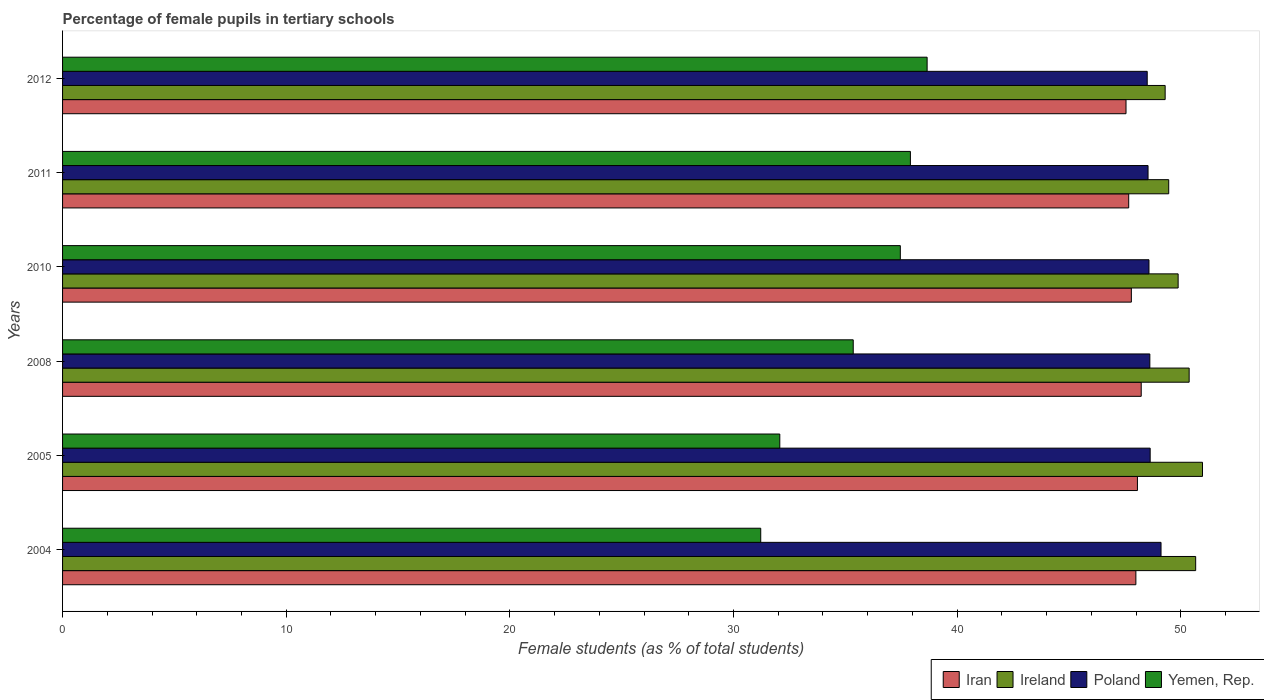How many groups of bars are there?
Provide a short and direct response. 6. Are the number of bars on each tick of the Y-axis equal?
Give a very brief answer. Yes. What is the label of the 4th group of bars from the top?
Your response must be concise. 2008. In how many cases, is the number of bars for a given year not equal to the number of legend labels?
Give a very brief answer. 0. What is the percentage of female pupils in tertiary schools in Poland in 2008?
Keep it short and to the point. 48.62. Across all years, what is the maximum percentage of female pupils in tertiary schools in Yemen, Rep.?
Ensure brevity in your answer.  38.66. Across all years, what is the minimum percentage of female pupils in tertiary schools in Iran?
Provide a succinct answer. 47.55. In which year was the percentage of female pupils in tertiary schools in Poland maximum?
Make the answer very short. 2004. In which year was the percentage of female pupils in tertiary schools in Iran minimum?
Give a very brief answer. 2012. What is the total percentage of female pupils in tertiary schools in Iran in the graph?
Ensure brevity in your answer.  287.3. What is the difference between the percentage of female pupils in tertiary schools in Iran in 2004 and that in 2005?
Provide a succinct answer. -0.07. What is the difference between the percentage of female pupils in tertiary schools in Yemen, Rep. in 2010 and the percentage of female pupils in tertiary schools in Iran in 2005?
Your answer should be compact. -10.6. What is the average percentage of female pupils in tertiary schools in Poland per year?
Give a very brief answer. 48.66. In the year 2004, what is the difference between the percentage of female pupils in tertiary schools in Ireland and percentage of female pupils in tertiary schools in Yemen, Rep.?
Provide a succinct answer. 19.45. What is the ratio of the percentage of female pupils in tertiary schools in Ireland in 2010 to that in 2011?
Ensure brevity in your answer.  1.01. Is the difference between the percentage of female pupils in tertiary schools in Ireland in 2011 and 2012 greater than the difference between the percentage of female pupils in tertiary schools in Yemen, Rep. in 2011 and 2012?
Your response must be concise. Yes. What is the difference between the highest and the second highest percentage of female pupils in tertiary schools in Poland?
Offer a terse response. 0.49. What is the difference between the highest and the lowest percentage of female pupils in tertiary schools in Iran?
Make the answer very short. 0.68. What does the 4th bar from the top in 2011 represents?
Offer a very short reply. Iran. What does the 1st bar from the bottom in 2011 represents?
Offer a very short reply. Iran. Is it the case that in every year, the sum of the percentage of female pupils in tertiary schools in Iran and percentage of female pupils in tertiary schools in Ireland is greater than the percentage of female pupils in tertiary schools in Poland?
Your answer should be compact. Yes. How many bars are there?
Ensure brevity in your answer.  24. Are all the bars in the graph horizontal?
Keep it short and to the point. Yes. How many years are there in the graph?
Your response must be concise. 6. Are the values on the major ticks of X-axis written in scientific E-notation?
Your answer should be compact. No. What is the title of the graph?
Provide a short and direct response. Percentage of female pupils in tertiary schools. Does "Channel Islands" appear as one of the legend labels in the graph?
Your response must be concise. No. What is the label or title of the X-axis?
Provide a short and direct response. Female students (as % of total students). What is the label or title of the Y-axis?
Keep it short and to the point. Years. What is the Female students (as % of total students) in Iran in 2004?
Provide a short and direct response. 47.99. What is the Female students (as % of total students) in Ireland in 2004?
Make the answer very short. 50.67. What is the Female students (as % of total students) of Poland in 2004?
Offer a terse response. 49.12. What is the Female students (as % of total students) of Yemen, Rep. in 2004?
Your response must be concise. 31.22. What is the Female students (as % of total students) in Iran in 2005?
Keep it short and to the point. 48.06. What is the Female students (as % of total students) of Ireland in 2005?
Ensure brevity in your answer.  50.97. What is the Female students (as % of total students) of Poland in 2005?
Give a very brief answer. 48.63. What is the Female students (as % of total students) of Yemen, Rep. in 2005?
Ensure brevity in your answer.  32.07. What is the Female students (as % of total students) in Iran in 2008?
Offer a terse response. 48.23. What is the Female students (as % of total students) in Ireland in 2008?
Keep it short and to the point. 50.38. What is the Female students (as % of total students) in Poland in 2008?
Ensure brevity in your answer.  48.62. What is the Female students (as % of total students) of Yemen, Rep. in 2008?
Provide a short and direct response. 35.35. What is the Female students (as % of total students) of Iran in 2010?
Offer a very short reply. 47.79. What is the Female students (as % of total students) of Ireland in 2010?
Your answer should be compact. 49.88. What is the Female students (as % of total students) in Poland in 2010?
Ensure brevity in your answer.  48.58. What is the Female students (as % of total students) in Yemen, Rep. in 2010?
Your response must be concise. 37.46. What is the Female students (as % of total students) of Iran in 2011?
Your answer should be very brief. 47.67. What is the Female students (as % of total students) in Ireland in 2011?
Make the answer very short. 49.46. What is the Female students (as % of total students) in Poland in 2011?
Provide a succinct answer. 48.54. What is the Female students (as % of total students) of Yemen, Rep. in 2011?
Provide a succinct answer. 37.91. What is the Female students (as % of total students) in Iran in 2012?
Keep it short and to the point. 47.55. What is the Female students (as % of total students) of Ireland in 2012?
Offer a very short reply. 49.3. What is the Female students (as % of total students) in Poland in 2012?
Make the answer very short. 48.5. What is the Female students (as % of total students) in Yemen, Rep. in 2012?
Your response must be concise. 38.66. Across all years, what is the maximum Female students (as % of total students) in Iran?
Offer a terse response. 48.23. Across all years, what is the maximum Female students (as % of total students) in Ireland?
Keep it short and to the point. 50.97. Across all years, what is the maximum Female students (as % of total students) of Poland?
Provide a succinct answer. 49.12. Across all years, what is the maximum Female students (as % of total students) in Yemen, Rep.?
Keep it short and to the point. 38.66. Across all years, what is the minimum Female students (as % of total students) of Iran?
Make the answer very short. 47.55. Across all years, what is the minimum Female students (as % of total students) in Ireland?
Offer a terse response. 49.3. Across all years, what is the minimum Female students (as % of total students) of Poland?
Make the answer very short. 48.5. Across all years, what is the minimum Female students (as % of total students) of Yemen, Rep.?
Make the answer very short. 31.22. What is the total Female students (as % of total students) in Iran in the graph?
Provide a short and direct response. 287.3. What is the total Female students (as % of total students) of Ireland in the graph?
Your answer should be very brief. 300.66. What is the total Female students (as % of total students) of Poland in the graph?
Make the answer very short. 291.98. What is the total Female students (as % of total students) in Yemen, Rep. in the graph?
Provide a short and direct response. 212.67. What is the difference between the Female students (as % of total students) in Iran in 2004 and that in 2005?
Offer a very short reply. -0.07. What is the difference between the Female students (as % of total students) of Ireland in 2004 and that in 2005?
Offer a terse response. -0.3. What is the difference between the Female students (as % of total students) in Poland in 2004 and that in 2005?
Your response must be concise. 0.49. What is the difference between the Female students (as % of total students) of Yemen, Rep. in 2004 and that in 2005?
Offer a terse response. -0.85. What is the difference between the Female students (as % of total students) in Iran in 2004 and that in 2008?
Provide a short and direct response. -0.24. What is the difference between the Female students (as % of total students) in Ireland in 2004 and that in 2008?
Make the answer very short. 0.29. What is the difference between the Female students (as % of total students) in Poland in 2004 and that in 2008?
Give a very brief answer. 0.5. What is the difference between the Female students (as % of total students) in Yemen, Rep. in 2004 and that in 2008?
Ensure brevity in your answer.  -4.14. What is the difference between the Female students (as % of total students) of Iran in 2004 and that in 2010?
Make the answer very short. 0.2. What is the difference between the Female students (as % of total students) in Ireland in 2004 and that in 2010?
Your answer should be compact. 0.78. What is the difference between the Female students (as % of total students) of Poland in 2004 and that in 2010?
Keep it short and to the point. 0.54. What is the difference between the Female students (as % of total students) in Yemen, Rep. in 2004 and that in 2010?
Give a very brief answer. -6.24. What is the difference between the Female students (as % of total students) in Iran in 2004 and that in 2011?
Provide a short and direct response. 0.32. What is the difference between the Female students (as % of total students) in Ireland in 2004 and that in 2011?
Provide a succinct answer. 1.21. What is the difference between the Female students (as % of total students) in Poland in 2004 and that in 2011?
Offer a very short reply. 0.58. What is the difference between the Female students (as % of total students) of Yemen, Rep. in 2004 and that in 2011?
Your answer should be very brief. -6.69. What is the difference between the Female students (as % of total students) of Iran in 2004 and that in 2012?
Offer a very short reply. 0.44. What is the difference between the Female students (as % of total students) in Ireland in 2004 and that in 2012?
Your answer should be very brief. 1.36. What is the difference between the Female students (as % of total students) in Poland in 2004 and that in 2012?
Offer a very short reply. 0.62. What is the difference between the Female students (as % of total students) of Yemen, Rep. in 2004 and that in 2012?
Give a very brief answer. -7.44. What is the difference between the Female students (as % of total students) in Iran in 2005 and that in 2008?
Offer a terse response. -0.17. What is the difference between the Female students (as % of total students) in Ireland in 2005 and that in 2008?
Your answer should be very brief. 0.6. What is the difference between the Female students (as % of total students) of Poland in 2005 and that in 2008?
Your answer should be very brief. 0.01. What is the difference between the Female students (as % of total students) in Yemen, Rep. in 2005 and that in 2008?
Provide a succinct answer. -3.28. What is the difference between the Female students (as % of total students) in Iran in 2005 and that in 2010?
Keep it short and to the point. 0.27. What is the difference between the Female students (as % of total students) in Ireland in 2005 and that in 2010?
Keep it short and to the point. 1.09. What is the difference between the Female students (as % of total students) of Poland in 2005 and that in 2010?
Provide a succinct answer. 0.05. What is the difference between the Female students (as % of total students) in Yemen, Rep. in 2005 and that in 2010?
Ensure brevity in your answer.  -5.39. What is the difference between the Female students (as % of total students) in Iran in 2005 and that in 2011?
Offer a terse response. 0.39. What is the difference between the Female students (as % of total students) in Ireland in 2005 and that in 2011?
Your response must be concise. 1.51. What is the difference between the Female students (as % of total students) of Poland in 2005 and that in 2011?
Give a very brief answer. 0.09. What is the difference between the Female students (as % of total students) of Yemen, Rep. in 2005 and that in 2011?
Provide a short and direct response. -5.84. What is the difference between the Female students (as % of total students) of Iran in 2005 and that in 2012?
Keep it short and to the point. 0.51. What is the difference between the Female students (as % of total students) in Ireland in 2005 and that in 2012?
Offer a very short reply. 1.67. What is the difference between the Female students (as % of total students) in Poland in 2005 and that in 2012?
Provide a succinct answer. 0.13. What is the difference between the Female students (as % of total students) in Yemen, Rep. in 2005 and that in 2012?
Make the answer very short. -6.59. What is the difference between the Female students (as % of total students) of Iran in 2008 and that in 2010?
Keep it short and to the point. 0.44. What is the difference between the Female students (as % of total students) in Ireland in 2008 and that in 2010?
Your answer should be compact. 0.49. What is the difference between the Female students (as % of total students) in Poland in 2008 and that in 2010?
Make the answer very short. 0.04. What is the difference between the Female students (as % of total students) of Yemen, Rep. in 2008 and that in 2010?
Offer a very short reply. -2.11. What is the difference between the Female students (as % of total students) in Iran in 2008 and that in 2011?
Make the answer very short. 0.56. What is the difference between the Female students (as % of total students) in Ireland in 2008 and that in 2011?
Keep it short and to the point. 0.91. What is the difference between the Female students (as % of total students) in Poland in 2008 and that in 2011?
Make the answer very short. 0.08. What is the difference between the Female students (as % of total students) in Yemen, Rep. in 2008 and that in 2011?
Your answer should be very brief. -2.56. What is the difference between the Female students (as % of total students) of Iran in 2008 and that in 2012?
Your answer should be compact. 0.68. What is the difference between the Female students (as % of total students) in Ireland in 2008 and that in 2012?
Provide a succinct answer. 1.07. What is the difference between the Female students (as % of total students) in Poland in 2008 and that in 2012?
Give a very brief answer. 0.12. What is the difference between the Female students (as % of total students) in Yemen, Rep. in 2008 and that in 2012?
Keep it short and to the point. -3.3. What is the difference between the Female students (as % of total students) of Iran in 2010 and that in 2011?
Your answer should be very brief. 0.12. What is the difference between the Female students (as % of total students) in Ireland in 2010 and that in 2011?
Your answer should be very brief. 0.42. What is the difference between the Female students (as % of total students) of Poland in 2010 and that in 2011?
Your answer should be very brief. 0.04. What is the difference between the Female students (as % of total students) of Yemen, Rep. in 2010 and that in 2011?
Ensure brevity in your answer.  -0.45. What is the difference between the Female students (as % of total students) in Iran in 2010 and that in 2012?
Give a very brief answer. 0.24. What is the difference between the Female students (as % of total students) in Ireland in 2010 and that in 2012?
Offer a terse response. 0.58. What is the difference between the Female students (as % of total students) of Poland in 2010 and that in 2012?
Your answer should be very brief. 0.08. What is the difference between the Female students (as % of total students) of Yemen, Rep. in 2010 and that in 2012?
Make the answer very short. -1.2. What is the difference between the Female students (as % of total students) in Iran in 2011 and that in 2012?
Your answer should be compact. 0.12. What is the difference between the Female students (as % of total students) of Ireland in 2011 and that in 2012?
Your response must be concise. 0.16. What is the difference between the Female students (as % of total students) in Poland in 2011 and that in 2012?
Provide a short and direct response. 0.04. What is the difference between the Female students (as % of total students) of Yemen, Rep. in 2011 and that in 2012?
Your answer should be very brief. -0.75. What is the difference between the Female students (as % of total students) in Iran in 2004 and the Female students (as % of total students) in Ireland in 2005?
Make the answer very short. -2.98. What is the difference between the Female students (as % of total students) of Iran in 2004 and the Female students (as % of total students) of Poland in 2005?
Offer a very short reply. -0.64. What is the difference between the Female students (as % of total students) in Iran in 2004 and the Female students (as % of total students) in Yemen, Rep. in 2005?
Offer a very short reply. 15.92. What is the difference between the Female students (as % of total students) of Ireland in 2004 and the Female students (as % of total students) of Poland in 2005?
Make the answer very short. 2.03. What is the difference between the Female students (as % of total students) of Ireland in 2004 and the Female students (as % of total students) of Yemen, Rep. in 2005?
Give a very brief answer. 18.6. What is the difference between the Female students (as % of total students) of Poland in 2004 and the Female students (as % of total students) of Yemen, Rep. in 2005?
Provide a short and direct response. 17.05. What is the difference between the Female students (as % of total students) in Iran in 2004 and the Female students (as % of total students) in Ireland in 2008?
Give a very brief answer. -2.38. What is the difference between the Female students (as % of total students) of Iran in 2004 and the Female students (as % of total students) of Poland in 2008?
Your response must be concise. -0.62. What is the difference between the Female students (as % of total students) in Iran in 2004 and the Female students (as % of total students) in Yemen, Rep. in 2008?
Ensure brevity in your answer.  12.64. What is the difference between the Female students (as % of total students) of Ireland in 2004 and the Female students (as % of total students) of Poland in 2008?
Ensure brevity in your answer.  2.05. What is the difference between the Female students (as % of total students) in Ireland in 2004 and the Female students (as % of total students) in Yemen, Rep. in 2008?
Your response must be concise. 15.31. What is the difference between the Female students (as % of total students) of Poland in 2004 and the Female students (as % of total students) of Yemen, Rep. in 2008?
Make the answer very short. 13.76. What is the difference between the Female students (as % of total students) in Iran in 2004 and the Female students (as % of total students) in Ireland in 2010?
Provide a short and direct response. -1.89. What is the difference between the Female students (as % of total students) of Iran in 2004 and the Female students (as % of total students) of Poland in 2010?
Your response must be concise. -0.59. What is the difference between the Female students (as % of total students) of Iran in 2004 and the Female students (as % of total students) of Yemen, Rep. in 2010?
Provide a short and direct response. 10.53. What is the difference between the Female students (as % of total students) of Ireland in 2004 and the Female students (as % of total students) of Poland in 2010?
Your answer should be compact. 2.09. What is the difference between the Female students (as % of total students) in Ireland in 2004 and the Female students (as % of total students) in Yemen, Rep. in 2010?
Your answer should be very brief. 13.21. What is the difference between the Female students (as % of total students) in Poland in 2004 and the Female students (as % of total students) in Yemen, Rep. in 2010?
Provide a succinct answer. 11.66. What is the difference between the Female students (as % of total students) of Iran in 2004 and the Female students (as % of total students) of Ireland in 2011?
Offer a very short reply. -1.47. What is the difference between the Female students (as % of total students) in Iran in 2004 and the Female students (as % of total students) in Poland in 2011?
Provide a succinct answer. -0.54. What is the difference between the Female students (as % of total students) of Iran in 2004 and the Female students (as % of total students) of Yemen, Rep. in 2011?
Ensure brevity in your answer.  10.08. What is the difference between the Female students (as % of total students) of Ireland in 2004 and the Female students (as % of total students) of Poland in 2011?
Give a very brief answer. 2.13. What is the difference between the Female students (as % of total students) in Ireland in 2004 and the Female students (as % of total students) in Yemen, Rep. in 2011?
Ensure brevity in your answer.  12.76. What is the difference between the Female students (as % of total students) in Poland in 2004 and the Female students (as % of total students) in Yemen, Rep. in 2011?
Provide a short and direct response. 11.21. What is the difference between the Female students (as % of total students) of Iran in 2004 and the Female students (as % of total students) of Ireland in 2012?
Your response must be concise. -1.31. What is the difference between the Female students (as % of total students) in Iran in 2004 and the Female students (as % of total students) in Poland in 2012?
Make the answer very short. -0.51. What is the difference between the Female students (as % of total students) in Iran in 2004 and the Female students (as % of total students) in Yemen, Rep. in 2012?
Make the answer very short. 9.33. What is the difference between the Female students (as % of total students) in Ireland in 2004 and the Female students (as % of total students) in Poland in 2012?
Ensure brevity in your answer.  2.17. What is the difference between the Female students (as % of total students) in Ireland in 2004 and the Female students (as % of total students) in Yemen, Rep. in 2012?
Your answer should be compact. 12.01. What is the difference between the Female students (as % of total students) in Poland in 2004 and the Female students (as % of total students) in Yemen, Rep. in 2012?
Provide a succinct answer. 10.46. What is the difference between the Female students (as % of total students) of Iran in 2005 and the Female students (as % of total students) of Ireland in 2008?
Make the answer very short. -2.31. What is the difference between the Female students (as % of total students) in Iran in 2005 and the Female students (as % of total students) in Poland in 2008?
Give a very brief answer. -0.56. What is the difference between the Female students (as % of total students) in Iran in 2005 and the Female students (as % of total students) in Yemen, Rep. in 2008?
Make the answer very short. 12.71. What is the difference between the Female students (as % of total students) in Ireland in 2005 and the Female students (as % of total students) in Poland in 2008?
Provide a short and direct response. 2.35. What is the difference between the Female students (as % of total students) of Ireland in 2005 and the Female students (as % of total students) of Yemen, Rep. in 2008?
Your answer should be compact. 15.62. What is the difference between the Female students (as % of total students) in Poland in 2005 and the Female students (as % of total students) in Yemen, Rep. in 2008?
Offer a terse response. 13.28. What is the difference between the Female students (as % of total students) in Iran in 2005 and the Female students (as % of total students) in Ireland in 2010?
Provide a short and direct response. -1.82. What is the difference between the Female students (as % of total students) in Iran in 2005 and the Female students (as % of total students) in Poland in 2010?
Ensure brevity in your answer.  -0.52. What is the difference between the Female students (as % of total students) of Iran in 2005 and the Female students (as % of total students) of Yemen, Rep. in 2010?
Keep it short and to the point. 10.6. What is the difference between the Female students (as % of total students) in Ireland in 2005 and the Female students (as % of total students) in Poland in 2010?
Give a very brief answer. 2.39. What is the difference between the Female students (as % of total students) of Ireland in 2005 and the Female students (as % of total students) of Yemen, Rep. in 2010?
Ensure brevity in your answer.  13.51. What is the difference between the Female students (as % of total students) in Poland in 2005 and the Female students (as % of total students) in Yemen, Rep. in 2010?
Provide a short and direct response. 11.17. What is the difference between the Female students (as % of total students) in Iran in 2005 and the Female students (as % of total students) in Ireland in 2011?
Give a very brief answer. -1.4. What is the difference between the Female students (as % of total students) of Iran in 2005 and the Female students (as % of total students) of Poland in 2011?
Offer a terse response. -0.47. What is the difference between the Female students (as % of total students) of Iran in 2005 and the Female students (as % of total students) of Yemen, Rep. in 2011?
Provide a succinct answer. 10.15. What is the difference between the Female students (as % of total students) in Ireland in 2005 and the Female students (as % of total students) in Poland in 2011?
Keep it short and to the point. 2.43. What is the difference between the Female students (as % of total students) in Ireland in 2005 and the Female students (as % of total students) in Yemen, Rep. in 2011?
Offer a terse response. 13.06. What is the difference between the Female students (as % of total students) of Poland in 2005 and the Female students (as % of total students) of Yemen, Rep. in 2011?
Keep it short and to the point. 10.72. What is the difference between the Female students (as % of total students) of Iran in 2005 and the Female students (as % of total students) of Ireland in 2012?
Provide a succinct answer. -1.24. What is the difference between the Female students (as % of total students) of Iran in 2005 and the Female students (as % of total students) of Poland in 2012?
Ensure brevity in your answer.  -0.44. What is the difference between the Female students (as % of total students) of Iran in 2005 and the Female students (as % of total students) of Yemen, Rep. in 2012?
Offer a very short reply. 9.4. What is the difference between the Female students (as % of total students) in Ireland in 2005 and the Female students (as % of total students) in Poland in 2012?
Offer a very short reply. 2.47. What is the difference between the Female students (as % of total students) in Ireland in 2005 and the Female students (as % of total students) in Yemen, Rep. in 2012?
Your response must be concise. 12.31. What is the difference between the Female students (as % of total students) of Poland in 2005 and the Female students (as % of total students) of Yemen, Rep. in 2012?
Ensure brevity in your answer.  9.97. What is the difference between the Female students (as % of total students) of Iran in 2008 and the Female students (as % of total students) of Ireland in 2010?
Provide a succinct answer. -1.65. What is the difference between the Female students (as % of total students) of Iran in 2008 and the Female students (as % of total students) of Poland in 2010?
Make the answer very short. -0.35. What is the difference between the Female students (as % of total students) of Iran in 2008 and the Female students (as % of total students) of Yemen, Rep. in 2010?
Ensure brevity in your answer.  10.77. What is the difference between the Female students (as % of total students) in Ireland in 2008 and the Female students (as % of total students) in Poland in 2010?
Make the answer very short. 1.8. What is the difference between the Female students (as % of total students) in Ireland in 2008 and the Female students (as % of total students) in Yemen, Rep. in 2010?
Make the answer very short. 12.92. What is the difference between the Female students (as % of total students) in Poland in 2008 and the Female students (as % of total students) in Yemen, Rep. in 2010?
Your response must be concise. 11.16. What is the difference between the Female students (as % of total students) of Iran in 2008 and the Female students (as % of total students) of Ireland in 2011?
Give a very brief answer. -1.23. What is the difference between the Female students (as % of total students) of Iran in 2008 and the Female students (as % of total students) of Poland in 2011?
Your answer should be compact. -0.31. What is the difference between the Female students (as % of total students) in Iran in 2008 and the Female students (as % of total students) in Yemen, Rep. in 2011?
Offer a terse response. 10.32. What is the difference between the Female students (as % of total students) of Ireland in 2008 and the Female students (as % of total students) of Poland in 2011?
Provide a succinct answer. 1.84. What is the difference between the Female students (as % of total students) in Ireland in 2008 and the Female students (as % of total students) in Yemen, Rep. in 2011?
Keep it short and to the point. 12.46. What is the difference between the Female students (as % of total students) in Poland in 2008 and the Female students (as % of total students) in Yemen, Rep. in 2011?
Your response must be concise. 10.71. What is the difference between the Female students (as % of total students) of Iran in 2008 and the Female students (as % of total students) of Ireland in 2012?
Ensure brevity in your answer.  -1.07. What is the difference between the Female students (as % of total students) in Iran in 2008 and the Female students (as % of total students) in Poland in 2012?
Your answer should be compact. -0.27. What is the difference between the Female students (as % of total students) in Iran in 2008 and the Female students (as % of total students) in Yemen, Rep. in 2012?
Give a very brief answer. 9.57. What is the difference between the Female students (as % of total students) of Ireland in 2008 and the Female students (as % of total students) of Poland in 2012?
Offer a very short reply. 1.88. What is the difference between the Female students (as % of total students) in Ireland in 2008 and the Female students (as % of total students) in Yemen, Rep. in 2012?
Provide a short and direct response. 11.72. What is the difference between the Female students (as % of total students) in Poland in 2008 and the Female students (as % of total students) in Yemen, Rep. in 2012?
Give a very brief answer. 9.96. What is the difference between the Female students (as % of total students) in Iran in 2010 and the Female students (as % of total students) in Ireland in 2011?
Offer a very short reply. -1.67. What is the difference between the Female students (as % of total students) of Iran in 2010 and the Female students (as % of total students) of Poland in 2011?
Your answer should be compact. -0.75. What is the difference between the Female students (as % of total students) of Iran in 2010 and the Female students (as % of total students) of Yemen, Rep. in 2011?
Ensure brevity in your answer.  9.88. What is the difference between the Female students (as % of total students) of Ireland in 2010 and the Female students (as % of total students) of Poland in 2011?
Provide a short and direct response. 1.35. What is the difference between the Female students (as % of total students) in Ireland in 2010 and the Female students (as % of total students) in Yemen, Rep. in 2011?
Your answer should be very brief. 11.97. What is the difference between the Female students (as % of total students) in Poland in 2010 and the Female students (as % of total students) in Yemen, Rep. in 2011?
Provide a short and direct response. 10.67. What is the difference between the Female students (as % of total students) of Iran in 2010 and the Female students (as % of total students) of Ireland in 2012?
Give a very brief answer. -1.51. What is the difference between the Female students (as % of total students) in Iran in 2010 and the Female students (as % of total students) in Poland in 2012?
Your answer should be compact. -0.71. What is the difference between the Female students (as % of total students) in Iran in 2010 and the Female students (as % of total students) in Yemen, Rep. in 2012?
Ensure brevity in your answer.  9.13. What is the difference between the Female students (as % of total students) in Ireland in 2010 and the Female students (as % of total students) in Poland in 2012?
Your response must be concise. 1.38. What is the difference between the Female students (as % of total students) in Ireland in 2010 and the Female students (as % of total students) in Yemen, Rep. in 2012?
Your answer should be compact. 11.22. What is the difference between the Female students (as % of total students) of Poland in 2010 and the Female students (as % of total students) of Yemen, Rep. in 2012?
Provide a short and direct response. 9.92. What is the difference between the Female students (as % of total students) in Iran in 2011 and the Female students (as % of total students) in Ireland in 2012?
Offer a very short reply. -1.63. What is the difference between the Female students (as % of total students) in Iran in 2011 and the Female students (as % of total students) in Poland in 2012?
Your answer should be compact. -0.83. What is the difference between the Female students (as % of total students) of Iran in 2011 and the Female students (as % of total students) of Yemen, Rep. in 2012?
Offer a terse response. 9.01. What is the difference between the Female students (as % of total students) of Ireland in 2011 and the Female students (as % of total students) of Poland in 2012?
Offer a very short reply. 0.96. What is the difference between the Female students (as % of total students) of Ireland in 2011 and the Female students (as % of total students) of Yemen, Rep. in 2012?
Make the answer very short. 10.8. What is the difference between the Female students (as % of total students) of Poland in 2011 and the Female students (as % of total students) of Yemen, Rep. in 2012?
Your response must be concise. 9.88. What is the average Female students (as % of total students) in Iran per year?
Provide a succinct answer. 47.88. What is the average Female students (as % of total students) of Ireland per year?
Offer a terse response. 50.11. What is the average Female students (as % of total students) in Poland per year?
Your answer should be compact. 48.66. What is the average Female students (as % of total students) of Yemen, Rep. per year?
Provide a succinct answer. 35.45. In the year 2004, what is the difference between the Female students (as % of total students) in Iran and Female students (as % of total students) in Ireland?
Offer a very short reply. -2.67. In the year 2004, what is the difference between the Female students (as % of total students) in Iran and Female students (as % of total students) in Poland?
Your response must be concise. -1.12. In the year 2004, what is the difference between the Female students (as % of total students) in Iran and Female students (as % of total students) in Yemen, Rep.?
Give a very brief answer. 16.77. In the year 2004, what is the difference between the Female students (as % of total students) of Ireland and Female students (as % of total students) of Poland?
Offer a very short reply. 1.55. In the year 2004, what is the difference between the Female students (as % of total students) of Ireland and Female students (as % of total students) of Yemen, Rep.?
Ensure brevity in your answer.  19.45. In the year 2004, what is the difference between the Female students (as % of total students) of Poland and Female students (as % of total students) of Yemen, Rep.?
Offer a very short reply. 17.9. In the year 2005, what is the difference between the Female students (as % of total students) of Iran and Female students (as % of total students) of Ireland?
Offer a very short reply. -2.91. In the year 2005, what is the difference between the Female students (as % of total students) of Iran and Female students (as % of total students) of Poland?
Your response must be concise. -0.57. In the year 2005, what is the difference between the Female students (as % of total students) of Iran and Female students (as % of total students) of Yemen, Rep.?
Ensure brevity in your answer.  15.99. In the year 2005, what is the difference between the Female students (as % of total students) in Ireland and Female students (as % of total students) in Poland?
Give a very brief answer. 2.34. In the year 2005, what is the difference between the Female students (as % of total students) in Ireland and Female students (as % of total students) in Yemen, Rep.?
Provide a short and direct response. 18.9. In the year 2005, what is the difference between the Female students (as % of total students) of Poland and Female students (as % of total students) of Yemen, Rep.?
Keep it short and to the point. 16.56. In the year 2008, what is the difference between the Female students (as % of total students) in Iran and Female students (as % of total students) in Ireland?
Your answer should be compact. -2.14. In the year 2008, what is the difference between the Female students (as % of total students) in Iran and Female students (as % of total students) in Poland?
Your answer should be very brief. -0.39. In the year 2008, what is the difference between the Female students (as % of total students) in Iran and Female students (as % of total students) in Yemen, Rep.?
Offer a terse response. 12.88. In the year 2008, what is the difference between the Female students (as % of total students) in Ireland and Female students (as % of total students) in Poland?
Ensure brevity in your answer.  1.76. In the year 2008, what is the difference between the Female students (as % of total students) in Ireland and Female students (as % of total students) in Yemen, Rep.?
Make the answer very short. 15.02. In the year 2008, what is the difference between the Female students (as % of total students) in Poland and Female students (as % of total students) in Yemen, Rep.?
Keep it short and to the point. 13.26. In the year 2010, what is the difference between the Female students (as % of total students) in Iran and Female students (as % of total students) in Ireland?
Your answer should be compact. -2.09. In the year 2010, what is the difference between the Female students (as % of total students) of Iran and Female students (as % of total students) of Poland?
Provide a short and direct response. -0.79. In the year 2010, what is the difference between the Female students (as % of total students) in Iran and Female students (as % of total students) in Yemen, Rep.?
Ensure brevity in your answer.  10.33. In the year 2010, what is the difference between the Female students (as % of total students) in Ireland and Female students (as % of total students) in Poland?
Offer a very short reply. 1.3. In the year 2010, what is the difference between the Female students (as % of total students) in Ireland and Female students (as % of total students) in Yemen, Rep.?
Provide a short and direct response. 12.42. In the year 2010, what is the difference between the Female students (as % of total students) of Poland and Female students (as % of total students) of Yemen, Rep.?
Your answer should be compact. 11.12. In the year 2011, what is the difference between the Female students (as % of total students) of Iran and Female students (as % of total students) of Ireland?
Give a very brief answer. -1.79. In the year 2011, what is the difference between the Female students (as % of total students) in Iran and Female students (as % of total students) in Poland?
Offer a terse response. -0.87. In the year 2011, what is the difference between the Female students (as % of total students) in Iran and Female students (as % of total students) in Yemen, Rep.?
Your answer should be very brief. 9.76. In the year 2011, what is the difference between the Female students (as % of total students) of Ireland and Female students (as % of total students) of Poland?
Ensure brevity in your answer.  0.92. In the year 2011, what is the difference between the Female students (as % of total students) of Ireland and Female students (as % of total students) of Yemen, Rep.?
Give a very brief answer. 11.55. In the year 2011, what is the difference between the Female students (as % of total students) in Poland and Female students (as % of total students) in Yemen, Rep.?
Make the answer very short. 10.63. In the year 2012, what is the difference between the Female students (as % of total students) of Iran and Female students (as % of total students) of Ireland?
Offer a terse response. -1.75. In the year 2012, what is the difference between the Female students (as % of total students) in Iran and Female students (as % of total students) in Poland?
Make the answer very short. -0.95. In the year 2012, what is the difference between the Female students (as % of total students) in Iran and Female students (as % of total students) in Yemen, Rep.?
Your answer should be compact. 8.89. In the year 2012, what is the difference between the Female students (as % of total students) in Ireland and Female students (as % of total students) in Poland?
Your answer should be very brief. 0.8. In the year 2012, what is the difference between the Female students (as % of total students) of Ireland and Female students (as % of total students) of Yemen, Rep.?
Make the answer very short. 10.64. In the year 2012, what is the difference between the Female students (as % of total students) in Poland and Female students (as % of total students) in Yemen, Rep.?
Offer a terse response. 9.84. What is the ratio of the Female students (as % of total students) of Yemen, Rep. in 2004 to that in 2005?
Your answer should be compact. 0.97. What is the ratio of the Female students (as % of total students) of Iran in 2004 to that in 2008?
Your response must be concise. 0.99. What is the ratio of the Female students (as % of total students) of Ireland in 2004 to that in 2008?
Offer a very short reply. 1.01. What is the ratio of the Female students (as % of total students) of Poland in 2004 to that in 2008?
Provide a succinct answer. 1.01. What is the ratio of the Female students (as % of total students) of Yemen, Rep. in 2004 to that in 2008?
Provide a succinct answer. 0.88. What is the ratio of the Female students (as % of total students) in Iran in 2004 to that in 2010?
Your answer should be compact. 1. What is the ratio of the Female students (as % of total students) in Ireland in 2004 to that in 2010?
Offer a terse response. 1.02. What is the ratio of the Female students (as % of total students) of Poland in 2004 to that in 2010?
Offer a very short reply. 1.01. What is the ratio of the Female students (as % of total students) of Yemen, Rep. in 2004 to that in 2010?
Make the answer very short. 0.83. What is the ratio of the Female students (as % of total students) in Ireland in 2004 to that in 2011?
Your answer should be very brief. 1.02. What is the ratio of the Female students (as % of total students) of Yemen, Rep. in 2004 to that in 2011?
Offer a very short reply. 0.82. What is the ratio of the Female students (as % of total students) in Iran in 2004 to that in 2012?
Provide a succinct answer. 1.01. What is the ratio of the Female students (as % of total students) in Ireland in 2004 to that in 2012?
Give a very brief answer. 1.03. What is the ratio of the Female students (as % of total students) in Poland in 2004 to that in 2012?
Your answer should be very brief. 1.01. What is the ratio of the Female students (as % of total students) of Yemen, Rep. in 2004 to that in 2012?
Provide a succinct answer. 0.81. What is the ratio of the Female students (as % of total students) of Iran in 2005 to that in 2008?
Provide a succinct answer. 1. What is the ratio of the Female students (as % of total students) in Ireland in 2005 to that in 2008?
Make the answer very short. 1.01. What is the ratio of the Female students (as % of total students) in Yemen, Rep. in 2005 to that in 2008?
Provide a short and direct response. 0.91. What is the ratio of the Female students (as % of total students) in Ireland in 2005 to that in 2010?
Provide a short and direct response. 1.02. What is the ratio of the Female students (as % of total students) in Poland in 2005 to that in 2010?
Provide a short and direct response. 1. What is the ratio of the Female students (as % of total students) in Yemen, Rep. in 2005 to that in 2010?
Your answer should be very brief. 0.86. What is the ratio of the Female students (as % of total students) in Iran in 2005 to that in 2011?
Provide a short and direct response. 1.01. What is the ratio of the Female students (as % of total students) in Ireland in 2005 to that in 2011?
Keep it short and to the point. 1.03. What is the ratio of the Female students (as % of total students) in Poland in 2005 to that in 2011?
Provide a succinct answer. 1. What is the ratio of the Female students (as % of total students) in Yemen, Rep. in 2005 to that in 2011?
Provide a succinct answer. 0.85. What is the ratio of the Female students (as % of total students) of Iran in 2005 to that in 2012?
Ensure brevity in your answer.  1.01. What is the ratio of the Female students (as % of total students) in Ireland in 2005 to that in 2012?
Give a very brief answer. 1.03. What is the ratio of the Female students (as % of total students) of Yemen, Rep. in 2005 to that in 2012?
Your answer should be compact. 0.83. What is the ratio of the Female students (as % of total students) of Iran in 2008 to that in 2010?
Make the answer very short. 1.01. What is the ratio of the Female students (as % of total students) in Ireland in 2008 to that in 2010?
Offer a very short reply. 1.01. What is the ratio of the Female students (as % of total students) in Poland in 2008 to that in 2010?
Your response must be concise. 1. What is the ratio of the Female students (as % of total students) of Yemen, Rep. in 2008 to that in 2010?
Your answer should be compact. 0.94. What is the ratio of the Female students (as % of total students) in Iran in 2008 to that in 2011?
Your answer should be very brief. 1.01. What is the ratio of the Female students (as % of total students) in Ireland in 2008 to that in 2011?
Your response must be concise. 1.02. What is the ratio of the Female students (as % of total students) in Poland in 2008 to that in 2011?
Your answer should be compact. 1. What is the ratio of the Female students (as % of total students) in Yemen, Rep. in 2008 to that in 2011?
Your answer should be compact. 0.93. What is the ratio of the Female students (as % of total students) in Iran in 2008 to that in 2012?
Provide a succinct answer. 1.01. What is the ratio of the Female students (as % of total students) of Ireland in 2008 to that in 2012?
Your response must be concise. 1.02. What is the ratio of the Female students (as % of total students) in Poland in 2008 to that in 2012?
Keep it short and to the point. 1. What is the ratio of the Female students (as % of total students) in Yemen, Rep. in 2008 to that in 2012?
Provide a short and direct response. 0.91. What is the ratio of the Female students (as % of total students) in Iran in 2010 to that in 2011?
Ensure brevity in your answer.  1. What is the ratio of the Female students (as % of total students) in Ireland in 2010 to that in 2011?
Offer a very short reply. 1.01. What is the ratio of the Female students (as % of total students) in Poland in 2010 to that in 2011?
Give a very brief answer. 1. What is the ratio of the Female students (as % of total students) of Iran in 2010 to that in 2012?
Your answer should be compact. 1. What is the ratio of the Female students (as % of total students) in Ireland in 2010 to that in 2012?
Your answer should be compact. 1.01. What is the ratio of the Female students (as % of total students) of Ireland in 2011 to that in 2012?
Make the answer very short. 1. What is the ratio of the Female students (as % of total students) of Poland in 2011 to that in 2012?
Offer a terse response. 1. What is the ratio of the Female students (as % of total students) in Yemen, Rep. in 2011 to that in 2012?
Make the answer very short. 0.98. What is the difference between the highest and the second highest Female students (as % of total students) of Iran?
Offer a very short reply. 0.17. What is the difference between the highest and the second highest Female students (as % of total students) in Ireland?
Your answer should be very brief. 0.3. What is the difference between the highest and the second highest Female students (as % of total students) of Poland?
Your answer should be compact. 0.49. What is the difference between the highest and the second highest Female students (as % of total students) of Yemen, Rep.?
Offer a terse response. 0.75. What is the difference between the highest and the lowest Female students (as % of total students) in Iran?
Provide a short and direct response. 0.68. What is the difference between the highest and the lowest Female students (as % of total students) in Ireland?
Provide a succinct answer. 1.67. What is the difference between the highest and the lowest Female students (as % of total students) of Poland?
Your answer should be very brief. 0.62. What is the difference between the highest and the lowest Female students (as % of total students) of Yemen, Rep.?
Provide a short and direct response. 7.44. 